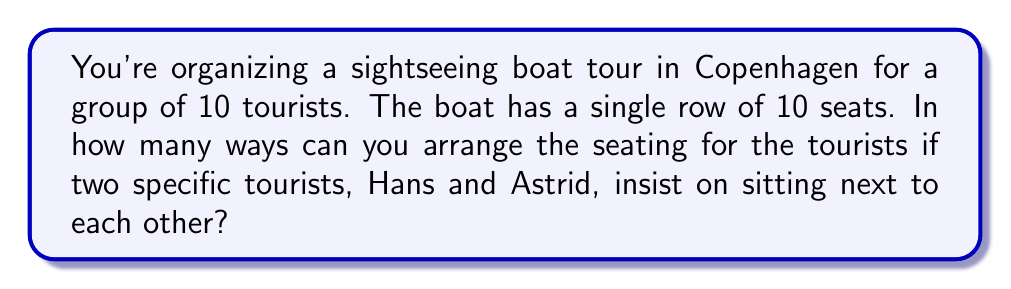What is the answer to this math problem? Let's approach this step-by-step:

1) First, consider Hans and Astrid as a single unit. This means we now have 9 units to arrange (the Hans-Astrid unit and the other 8 tourists).

2) The number of ways to arrange 9 units in a row is given by the permutation formula:
   $$P(9,9) = 9! = 362,880$$

3) However, Hans and Astrid can also switch positions between themselves. This gives us 2 possibilities for each arrangement we counted in step 2.

4) Therefore, we need to multiply our result by 2:
   $$362,880 \times 2 = 725,760$$

5) This final result gives us the total number of possible seating arrangements where Hans and Astrid are always seated next to each other.

The calculation can be summarized as:
$$9! \times 2 = 362,880 \times 2 = 725,760$$
Answer: 725,760 